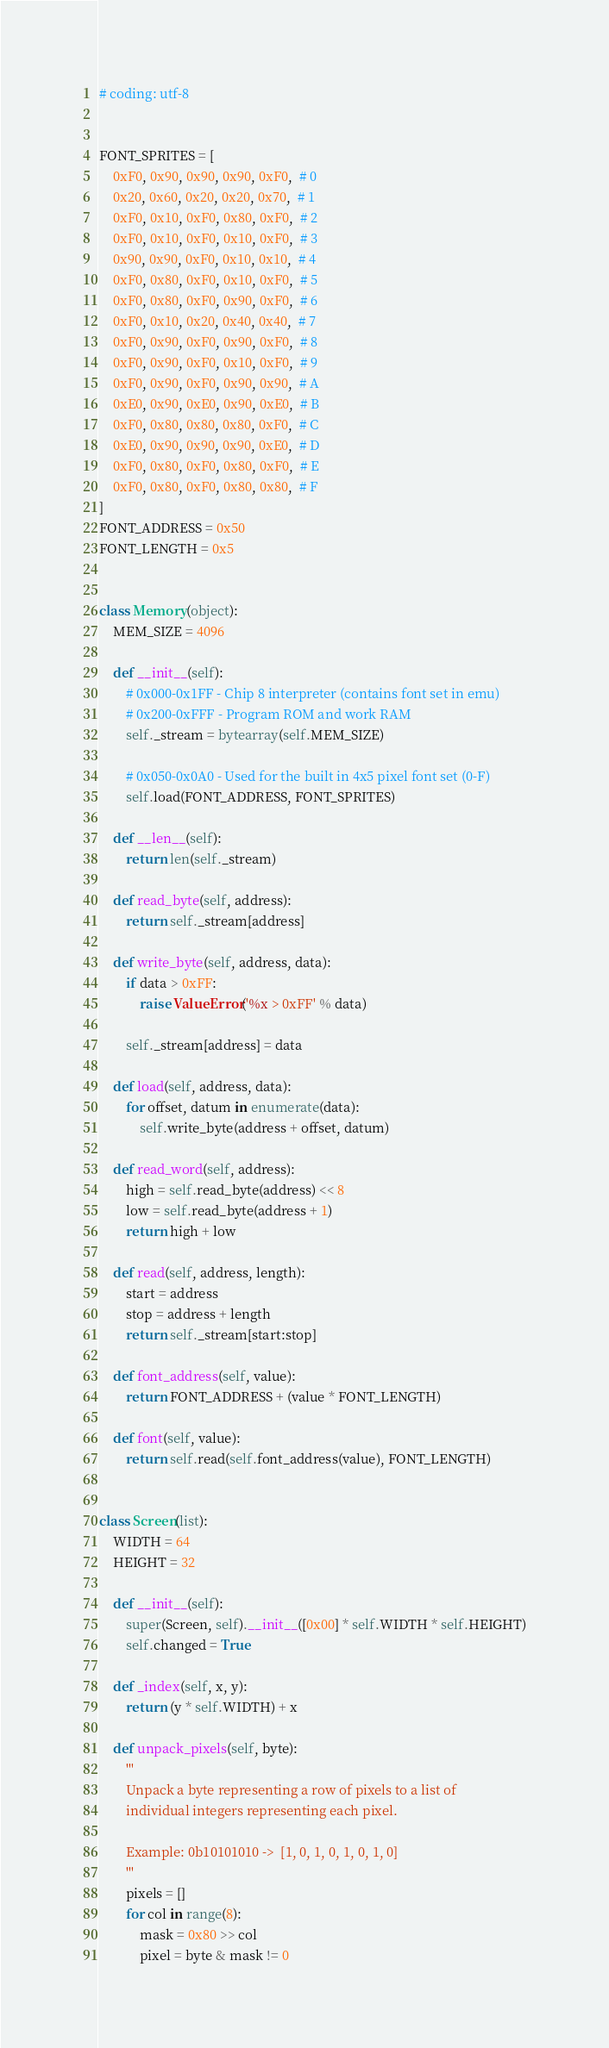Convert code to text. <code><loc_0><loc_0><loc_500><loc_500><_Python_># coding: utf-8


FONT_SPRITES = [
    0xF0, 0x90, 0x90, 0x90, 0xF0,  # 0
    0x20, 0x60, 0x20, 0x20, 0x70,  # 1
    0xF0, 0x10, 0xF0, 0x80, 0xF0,  # 2
    0xF0, 0x10, 0xF0, 0x10, 0xF0,  # 3
    0x90, 0x90, 0xF0, 0x10, 0x10,  # 4
    0xF0, 0x80, 0xF0, 0x10, 0xF0,  # 5
    0xF0, 0x80, 0xF0, 0x90, 0xF0,  # 6
    0xF0, 0x10, 0x20, 0x40, 0x40,  # 7
    0xF0, 0x90, 0xF0, 0x90, 0xF0,  # 8
    0xF0, 0x90, 0xF0, 0x10, 0xF0,  # 9
    0xF0, 0x90, 0xF0, 0x90, 0x90,  # A
    0xE0, 0x90, 0xE0, 0x90, 0xE0,  # B
    0xF0, 0x80, 0x80, 0x80, 0xF0,  # C
    0xE0, 0x90, 0x90, 0x90, 0xE0,  # D
    0xF0, 0x80, 0xF0, 0x80, 0xF0,  # E
    0xF0, 0x80, 0xF0, 0x80, 0x80,  # F
]
FONT_ADDRESS = 0x50
FONT_LENGTH = 0x5


class Memory(object):
    MEM_SIZE = 4096

    def __init__(self):
        # 0x000-0x1FF - Chip 8 interpreter (contains font set in emu)
        # 0x200-0xFFF - Program ROM and work RAM
        self._stream = bytearray(self.MEM_SIZE)

        # 0x050-0x0A0 - Used for the built in 4x5 pixel font set (0-F)
        self.load(FONT_ADDRESS, FONT_SPRITES)

    def __len__(self):
        return len(self._stream)

    def read_byte(self, address):
        return self._stream[address]

    def write_byte(self, address, data):
        if data > 0xFF:
            raise ValueError('%x > 0xFF' % data)

        self._stream[address] = data

    def load(self, address, data):
        for offset, datum in enumerate(data):
            self.write_byte(address + offset, datum)

    def read_word(self, address):
        high = self.read_byte(address) << 8
        low = self.read_byte(address + 1)
        return high + low

    def read(self, address, length):
        start = address
        stop = address + length
        return self._stream[start:stop]

    def font_address(self, value):
        return FONT_ADDRESS + (value * FONT_LENGTH)

    def font(self, value):
        return self.read(self.font_address(value), FONT_LENGTH)


class Screen(list):
    WIDTH = 64
    HEIGHT = 32

    def __init__(self):
        super(Screen, self).__init__([0x00] * self.WIDTH * self.HEIGHT)
        self.changed = True

    def _index(self, x, y):
        return (y * self.WIDTH) + x

    def unpack_pixels(self, byte):
        '''
        Unpack a byte representing a row of pixels to a list of
        individual integers representing each pixel.

        Example: 0b10101010 ->  [1, 0, 1, 0, 1, 0, 1, 0]
        '''
        pixels = []
        for col in range(8):
            mask = 0x80 >> col
            pixel = byte & mask != 0</code> 